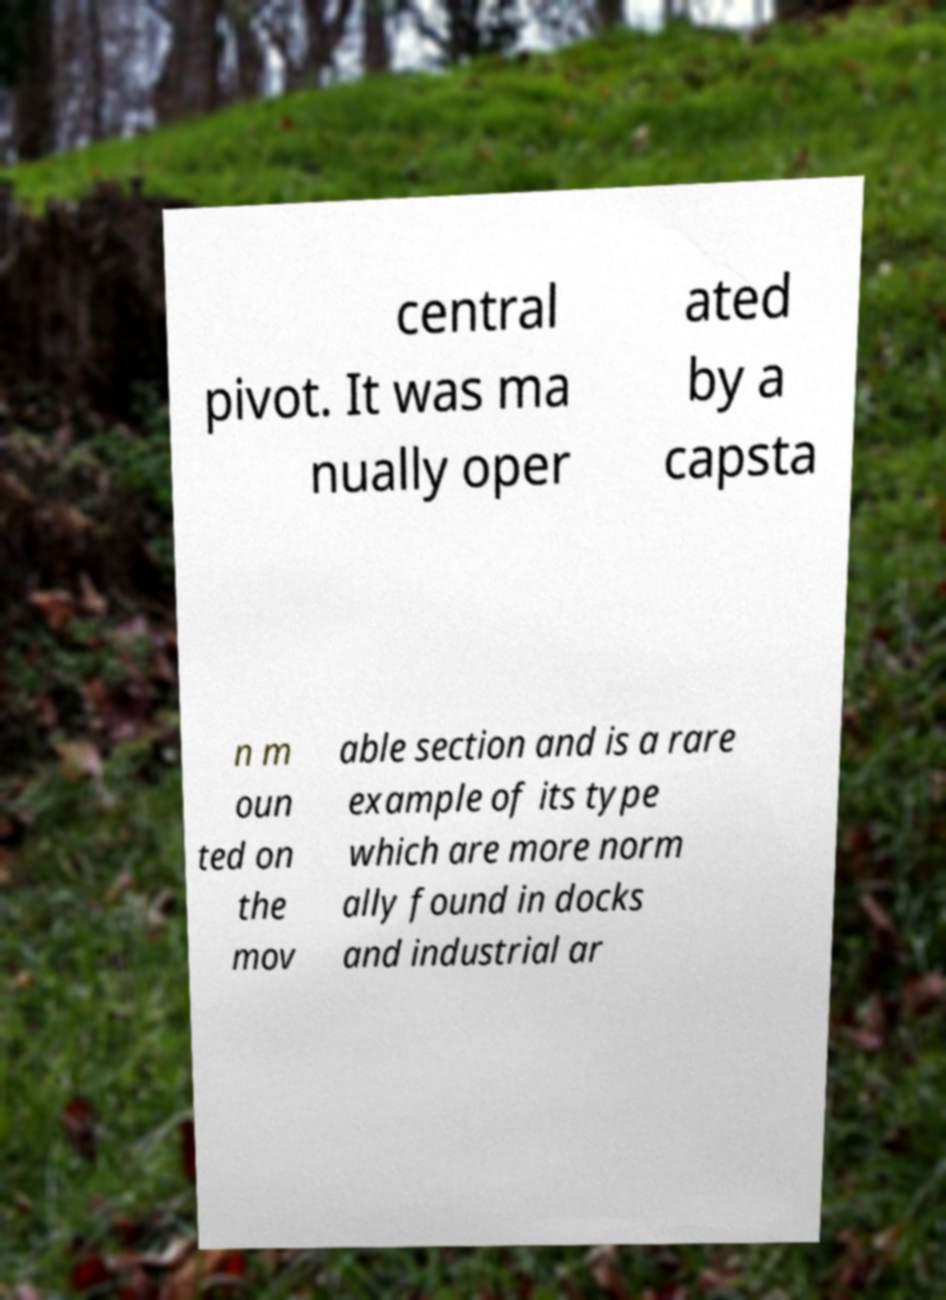Could you extract and type out the text from this image? central pivot. It was ma nually oper ated by a capsta n m oun ted on the mov able section and is a rare example of its type which are more norm ally found in docks and industrial ar 